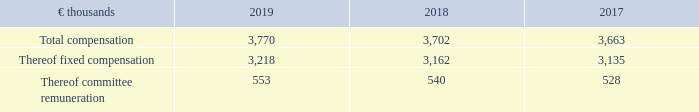The total annual compensation of the Supervisory Board members is as follows:
Supervisory Board Compensation
The Supervisory Board members do not receive any share-based payment for their services. As far as members who are employee representatives on the Supervisory Board receive share-based payment, such compensation is for their services as employees only and is unrelated to their status as members of the Supervisory Board.
What was the total compensation in 2019?
Answer scale should be: thousand. 3,770. What was the  Thereof committee remuneration  in 2018?
Answer scale should be: thousand. 540. In which years was the total annual compensation calculated in? 2019, 2018, 2017. In which year was the amount Thereof committee remuneration the largest? 553>540>528
Answer: 2019. What was the change in the amount Thereof committee remuneration in 2019 from 2018?
Answer scale should be: thousand. 553-540
Answer: 13. What was the percentage change in the amount Thereof committee remuneration in 2019 from 2018?
Answer scale should be: percent. (553-540)/540
Answer: 2.41. 